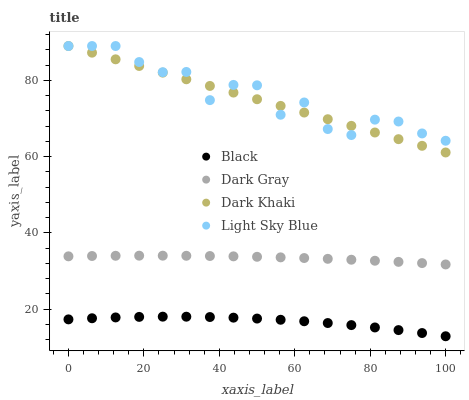Does Black have the minimum area under the curve?
Answer yes or no. Yes. Does Light Sky Blue have the maximum area under the curve?
Answer yes or no. Yes. Does Dark Khaki have the minimum area under the curve?
Answer yes or no. No. Does Dark Khaki have the maximum area under the curve?
Answer yes or no. No. Is Dark Khaki the smoothest?
Answer yes or no. Yes. Is Light Sky Blue the roughest?
Answer yes or no. Yes. Is Light Sky Blue the smoothest?
Answer yes or no. No. Is Dark Khaki the roughest?
Answer yes or no. No. Does Black have the lowest value?
Answer yes or no. Yes. Does Dark Khaki have the lowest value?
Answer yes or no. No. Does Light Sky Blue have the highest value?
Answer yes or no. Yes. Does Black have the highest value?
Answer yes or no. No. Is Black less than Dark Khaki?
Answer yes or no. Yes. Is Dark Khaki greater than Black?
Answer yes or no. Yes. Does Dark Khaki intersect Light Sky Blue?
Answer yes or no. Yes. Is Dark Khaki less than Light Sky Blue?
Answer yes or no. No. Is Dark Khaki greater than Light Sky Blue?
Answer yes or no. No. Does Black intersect Dark Khaki?
Answer yes or no. No. 